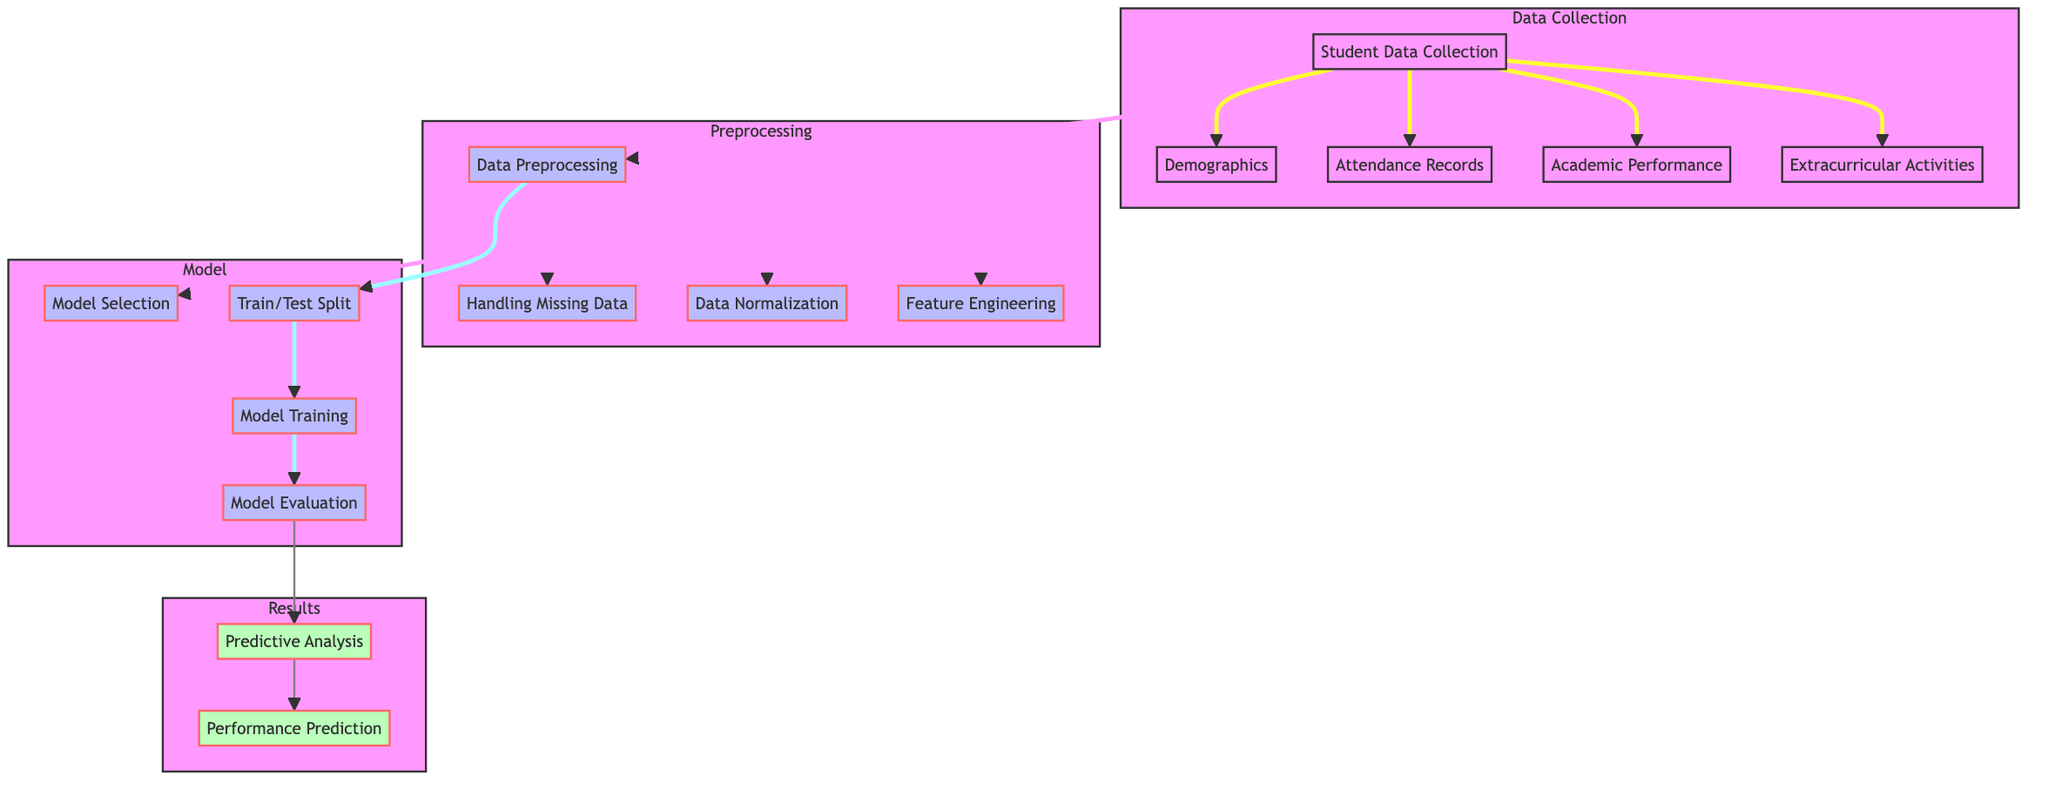What are the three types of data collected? The diagram shows four data types collected: demographics, attendance records, academic performance, and extracurricular activities. These are listed under the "Data Collection" section, indicating that they are fundamental components of the data collection step.
Answer: demographics, attendance records, academic performance, extracurricular activities How many preprocessing steps are there? The "Preprocessing" subgraph contains three distinct steps: handling missing data, data normalization, and feature engineering. Each of these is visually represented as an independent node under the preprocessing category.
Answer: 3 What follows data preprocessing? After data preprocessing, the process continues with model selection and train/test split as indicated by the arrows stemming from the data preprocessing node. This shows the flow of operations leading to model-related tasks.
Answer: model selection and train/test split Which node does model evaluation lead to? The "Model Evaluation" node points directly to the "Predictive Analysis" node, as indicated by the arrow connecting them. This shows that the evaluation step is crucial for the predictive analysis stage.
Answer: Predictive Analysis What is the purpose of feature engineering? Feature engineering is aimed at transforming raw data into informative features that can improve model performance. In the diagram, this node is explicitly included in the preprocessing steps, implying its importance in preparing data for modeling.
Answer: Improve model performance What type of analysis is depicted in the diagram? The diagram represents predictive analysis, as indicated by the "Predictive Analysis" node in the results subgraph, reflecting the focus of the entire framework on predicting academic performance based on prior inputs.
Answer: Predictive Analysis 